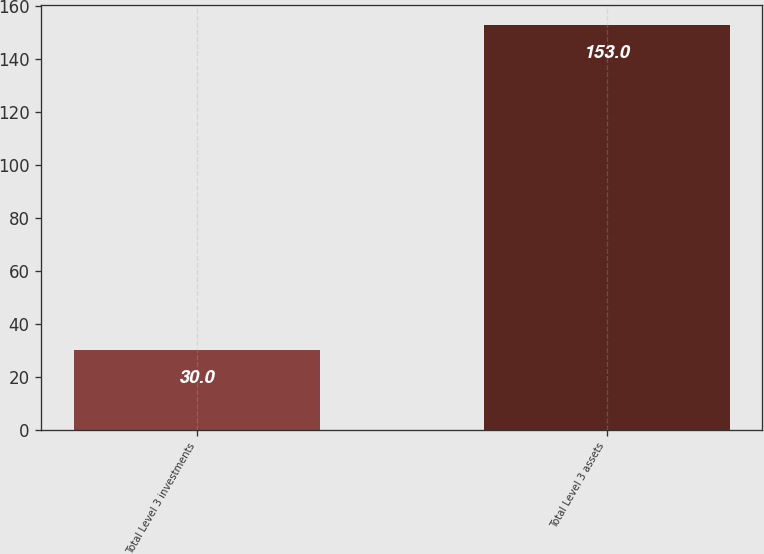Convert chart to OTSL. <chart><loc_0><loc_0><loc_500><loc_500><bar_chart><fcel>Total Level 3 investments<fcel>Total Level 3 assets<nl><fcel>30<fcel>153<nl></chart> 